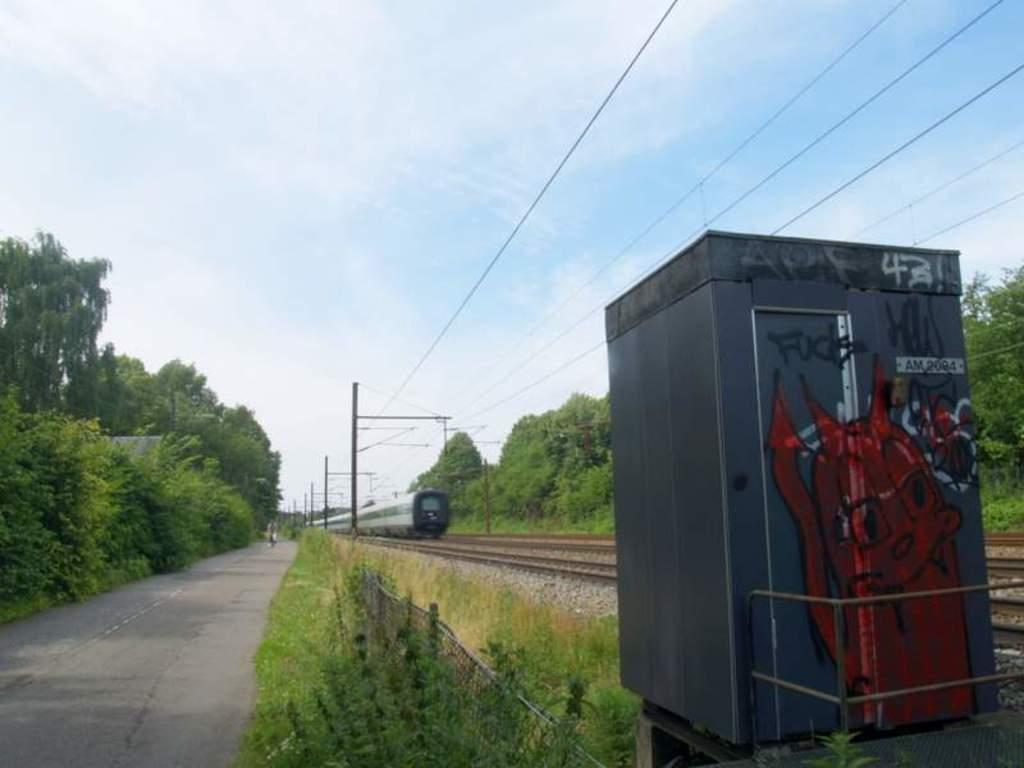What is the main subject of the image? The main subject of the image is a train on the track. What can be seen in the background of the image? There are trees, poles, wires, grass, and a booth visible in the background. What is the condition of the sky in the image? The sky is visible in the image, and clouds are present. Can you tell me how many grapes are hanging from the trees in the image? There are no grapes visible in the image; the trees are not mentioned as having any fruit. Is there a volcano erupting in the image? There is no volcano present in the image; the focus is on the train and the surrounding environment. 